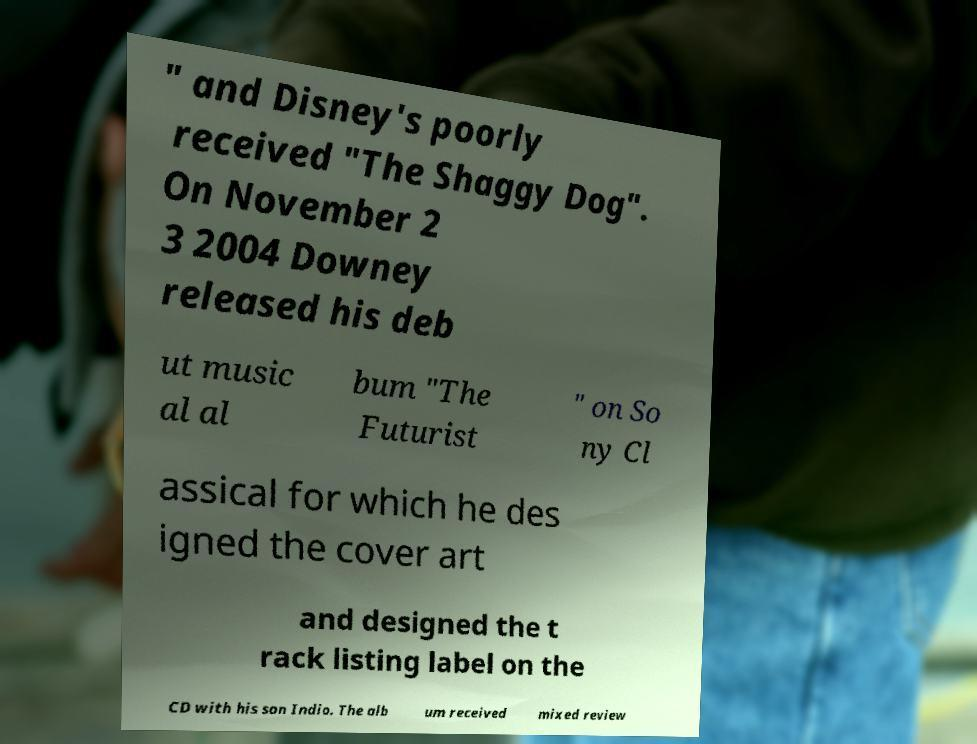Can you read and provide the text displayed in the image?This photo seems to have some interesting text. Can you extract and type it out for me? " and Disney's poorly received "The Shaggy Dog". On November 2 3 2004 Downey released his deb ut music al al bum "The Futurist " on So ny Cl assical for which he des igned the cover art and designed the t rack listing label on the CD with his son Indio. The alb um received mixed review 